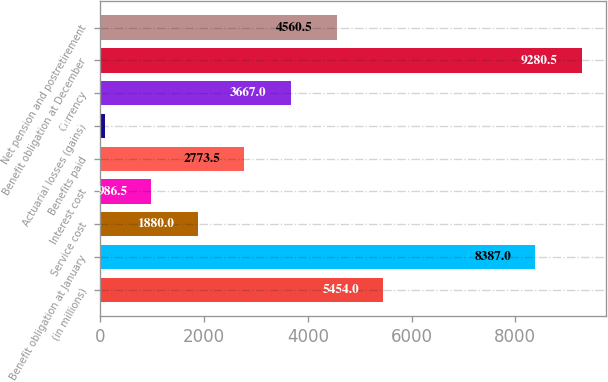Convert chart to OTSL. <chart><loc_0><loc_0><loc_500><loc_500><bar_chart><fcel>(in millions)<fcel>Benefit obligation at January<fcel>Service cost<fcel>Interest cost<fcel>Benefits paid<fcel>Actuarial losses (gains)<fcel>Currency<fcel>Benefit obligation at December<fcel>Net pension and postretirement<nl><fcel>5454<fcel>8387<fcel>1880<fcel>986.5<fcel>2773.5<fcel>93<fcel>3667<fcel>9280.5<fcel>4560.5<nl></chart> 